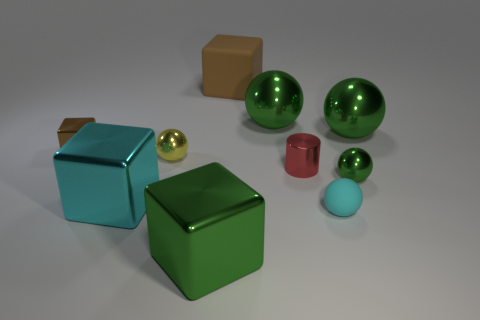What can you infer about the environment in which these objects are placed? The objects are arranged on a flat, matte surface with a neutral color, which alongside the shadows cast, suggests an environment with a single, diffused light source. The absence of any distinct background elements or additional context indicates that this could be a controlled setting, likely designed for display or a still-life composition. 